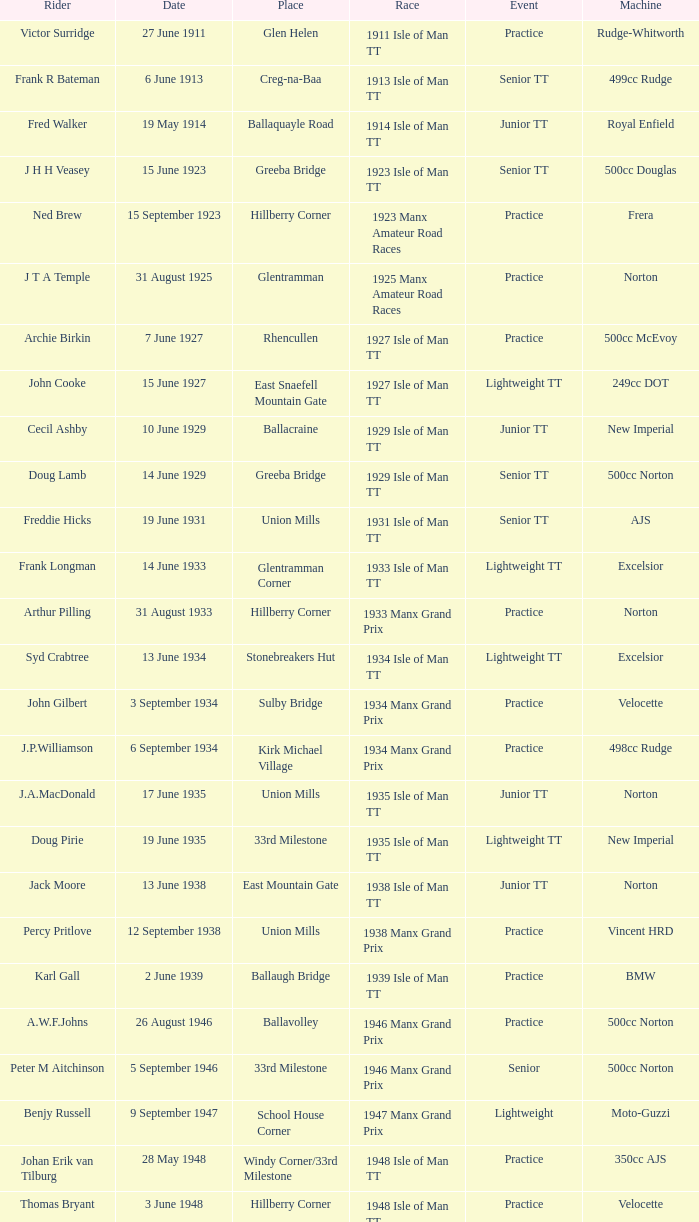Harry l Stephen rides a Norton machine on what date? 8 June 1953. 